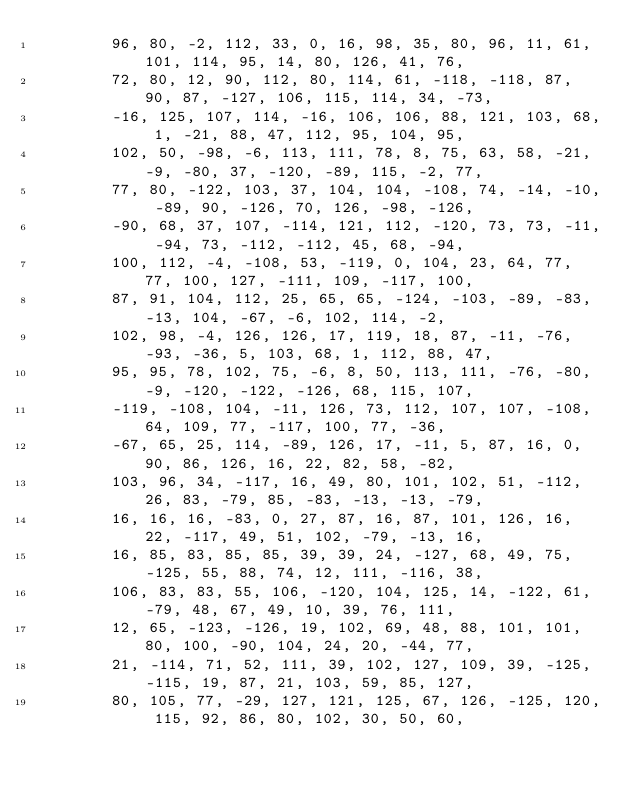<code> <loc_0><loc_0><loc_500><loc_500><_Kotlin_>        96, 80, -2, 112, 33, 0, 16, 98, 35, 80, 96, 11, 61, 101, 114, 95, 14, 80, 126, 41, 76,
        72, 80, 12, 90, 112, 80, 114, 61, -118, -118, 87, 90, 87, -127, 106, 115, 114, 34, -73,
        -16, 125, 107, 114, -16, 106, 106, 88, 121, 103, 68, 1, -21, 88, 47, 112, 95, 104, 95,
        102, 50, -98, -6, 113, 111, 78, 8, 75, 63, 58, -21, -9, -80, 37, -120, -89, 115, -2, 77,
        77, 80, -122, 103, 37, 104, 104, -108, 74, -14, -10, -89, 90, -126, 70, 126, -98, -126,
        -90, 68, 37, 107, -114, 121, 112, -120, 73, 73, -11, -94, 73, -112, -112, 45, 68, -94,
        100, 112, -4, -108, 53, -119, 0, 104, 23, 64, 77, 77, 100, 127, -111, 109, -117, 100,
        87, 91, 104, 112, 25, 65, 65, -124, -103, -89, -83, -13, 104, -67, -6, 102, 114, -2,
        102, 98, -4, 126, 126, 17, 119, 18, 87, -11, -76, -93, -36, 5, 103, 68, 1, 112, 88, 47,
        95, 95, 78, 102, 75, -6, 8, 50, 113, 111, -76, -80, -9, -120, -122, -126, 68, 115, 107,
        -119, -108, 104, -11, 126, 73, 112, 107, 107, -108, 64, 109, 77, -117, 100, 77, -36,
        -67, 65, 25, 114, -89, 126, 17, -11, 5, 87, 16, 0, 90, 86, 126, 16, 22, 82, 58, -82,
        103, 96, 34, -117, 16, 49, 80, 101, 102, 51, -112, 26, 83, -79, 85, -83, -13, -13, -79,
        16, 16, 16, -83, 0, 27, 87, 16, 87, 101, 126, 16, 22, -117, 49, 51, 102, -79, -13, 16,
        16, 85, 83, 85, 85, 39, 39, 24, -127, 68, 49, 75, -125, 55, 88, 74, 12, 111, -116, 38,
        106, 83, 83, 55, 106, -120, 104, 125, 14, -122, 61, -79, 48, 67, 49, 10, 39, 76, 111,
        12, 65, -123, -126, 19, 102, 69, 48, 88, 101, 101, 80, 100, -90, 104, 24, 20, -44, 77,
        21, -114, 71, 52, 111, 39, 102, 127, 109, 39, -125, -115, 19, 87, 21, 103, 59, 85, 127,
        80, 105, 77, -29, 127, 121, 125, 67, 126, -125, 120, 115, 92, 86, 80, 102, 30, 50, 60,</code> 